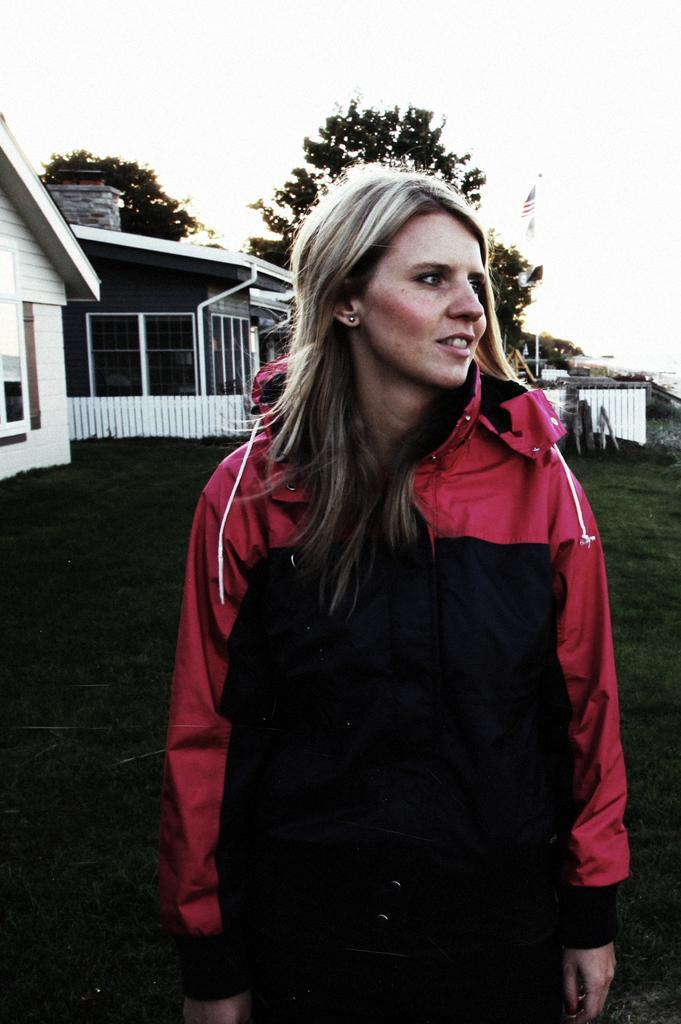In one or two sentences, can you explain what this image depicts? In this image I can see a woman is standing, she wore black and red color coat, behind her there are houses and trees. At the top it is the sky. 